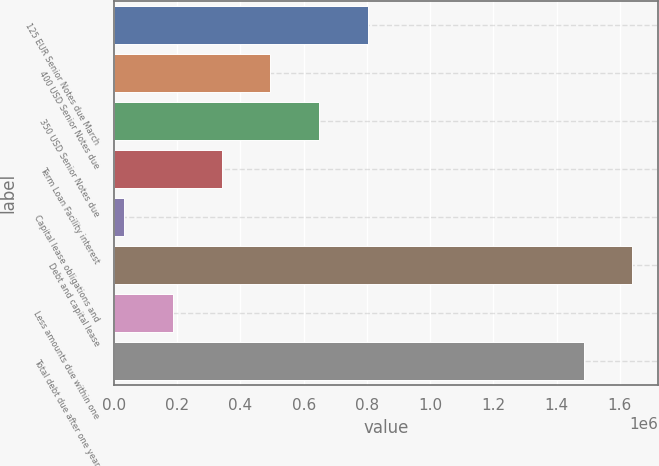Convert chart. <chart><loc_0><loc_0><loc_500><loc_500><bar_chart><fcel>125 EUR Senior Notes due March<fcel>400 USD Senior Notes due<fcel>350 USD Senior Notes due<fcel>Term Loan Facility interest<fcel>Capital lease obligations and<fcel>Debt and capital lease<fcel>Less amounts due within one<fcel>Total debt due after one year<nl><fcel>801954<fcel>494487<fcel>648221<fcel>340753<fcel>33286<fcel>1.63899e+06<fcel>187020<fcel>1.48526e+06<nl></chart> 